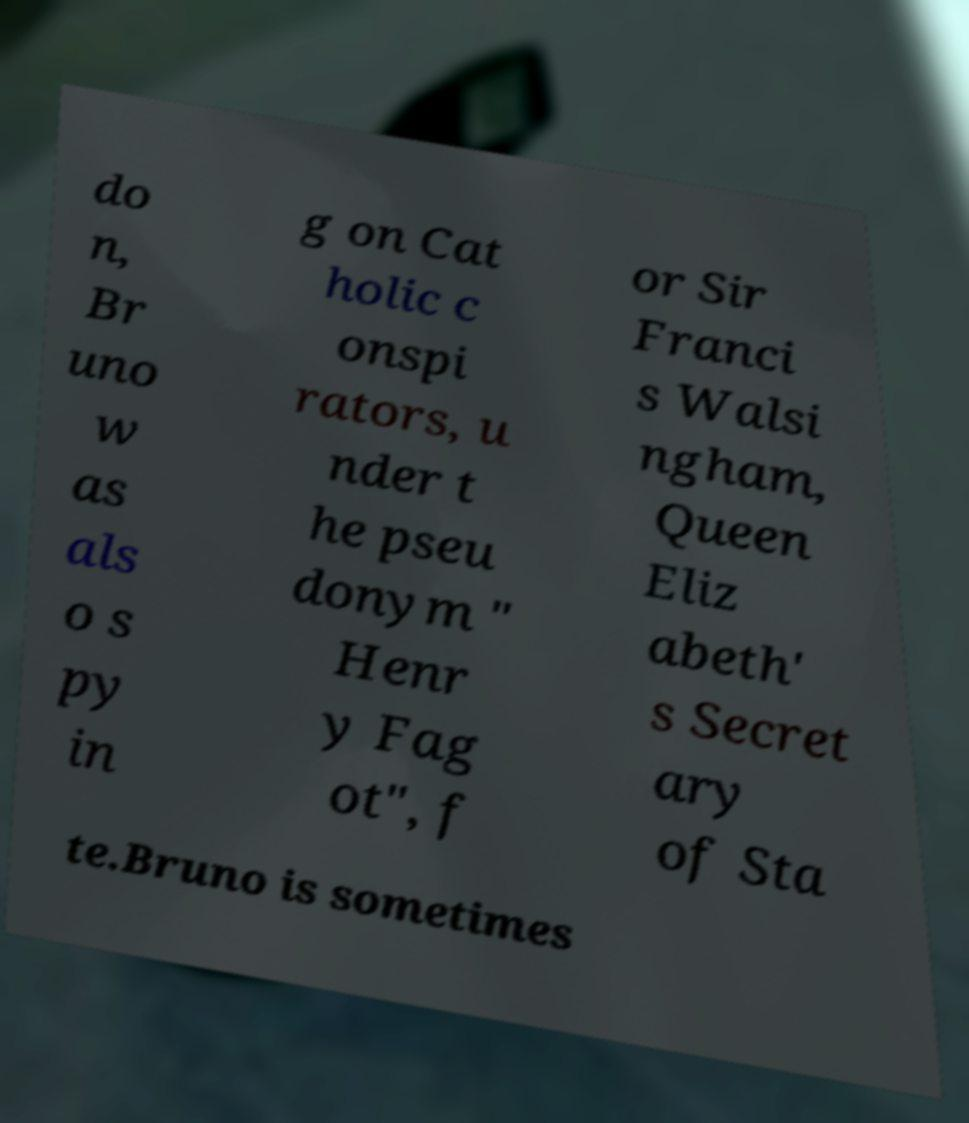Can you read and provide the text displayed in the image?This photo seems to have some interesting text. Can you extract and type it out for me? do n, Br uno w as als o s py in g on Cat holic c onspi rators, u nder t he pseu donym " Henr y Fag ot", f or Sir Franci s Walsi ngham, Queen Eliz abeth' s Secret ary of Sta te.Bruno is sometimes 